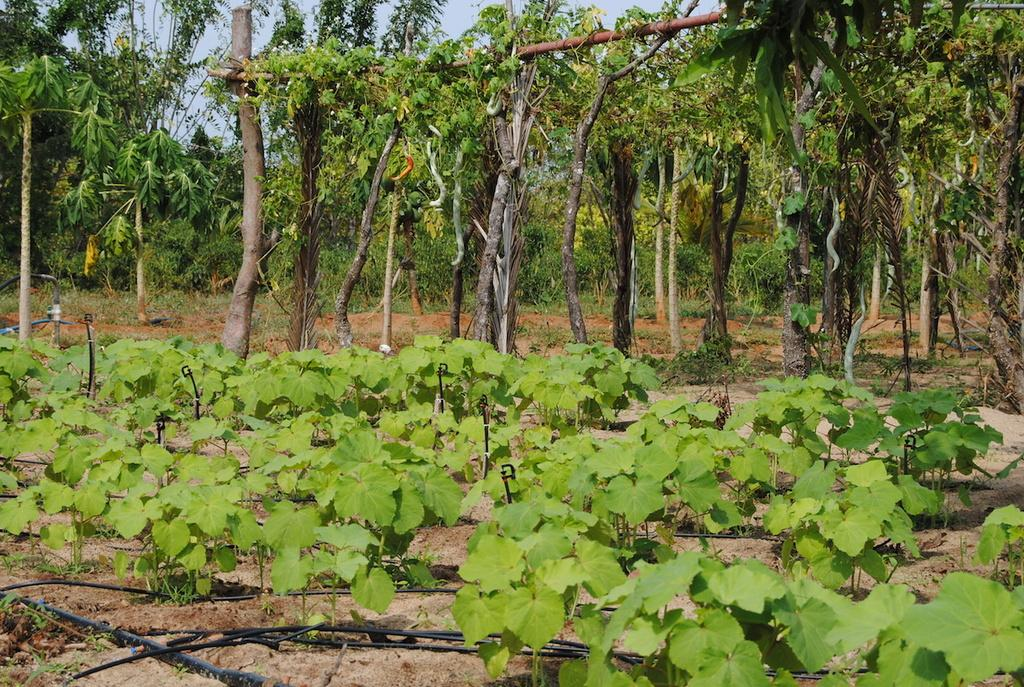What is located at the bottom of the picture? There are plants and soil at the bottom of the picture. What type of objects can be seen at the bottom of the picture? There are black-colored pipes at the bottom of the picture. What can be seen in the background of the image? There are trees and the sky visible in the background of the image. How does the crowd express their hate towards the unit in the image? There is no crowd, hate, or unit present in the image. The image features plants, soil, black-colored pipes, trees, and the sky. 